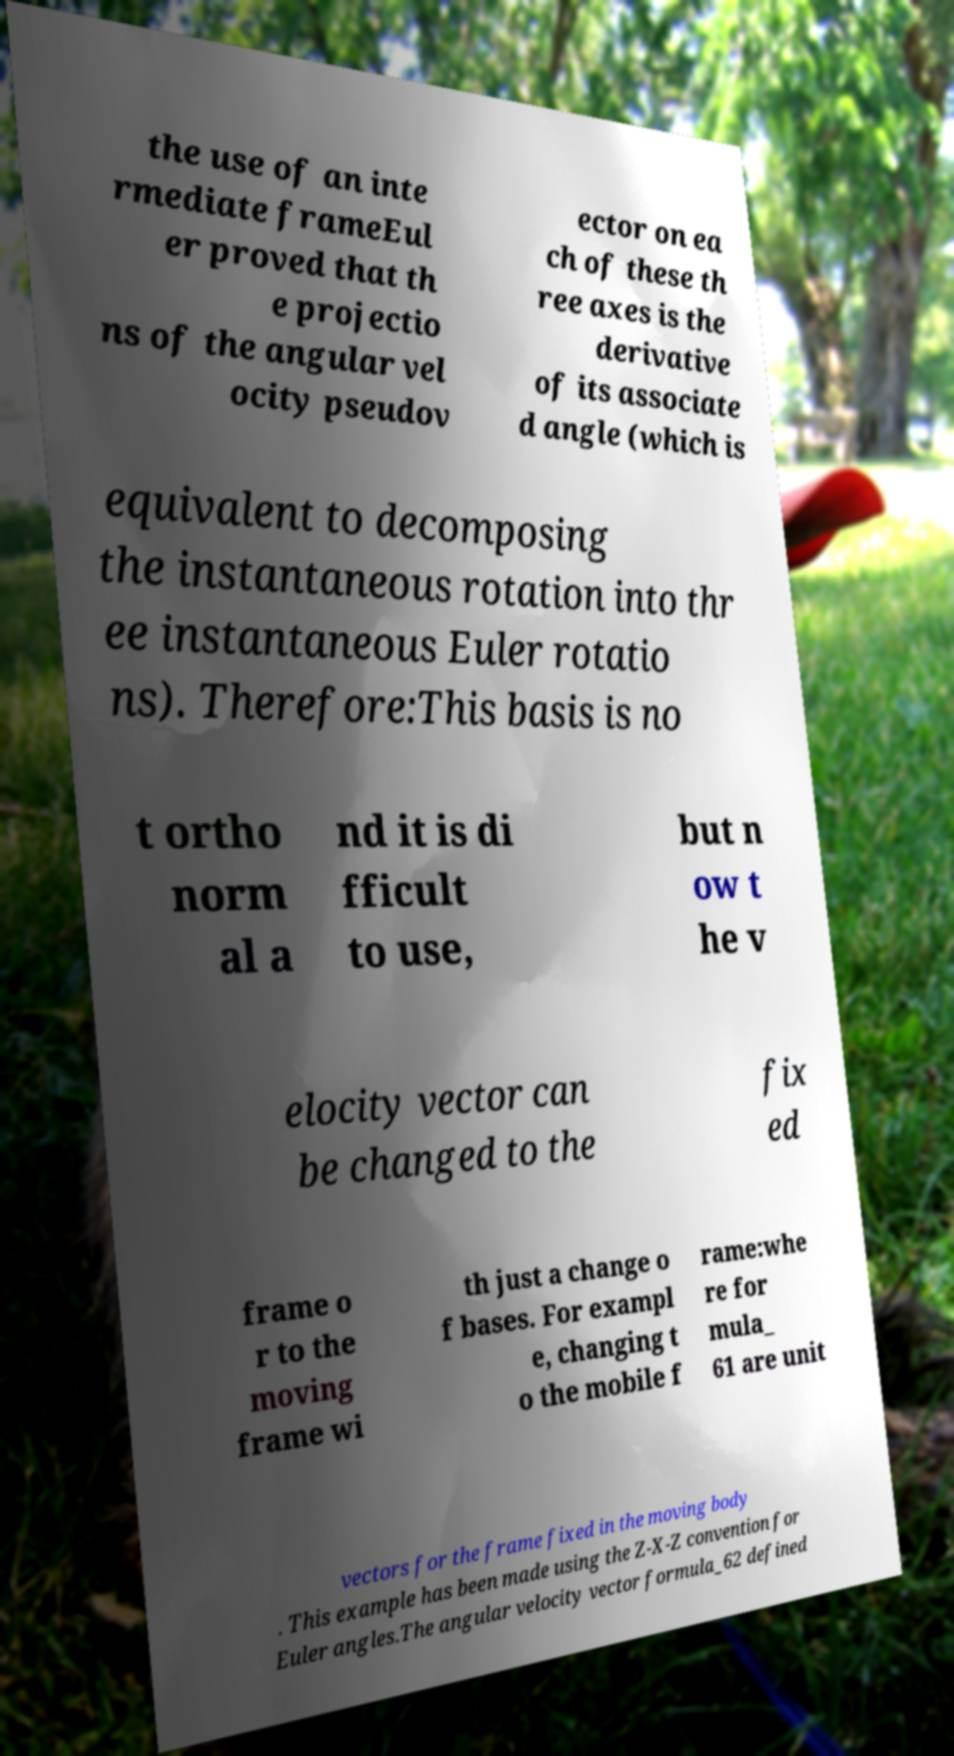Can you accurately transcribe the text from the provided image for me? the use of an inte rmediate frameEul er proved that th e projectio ns of the angular vel ocity pseudov ector on ea ch of these th ree axes is the derivative of its associate d angle (which is equivalent to decomposing the instantaneous rotation into thr ee instantaneous Euler rotatio ns). Therefore:This basis is no t ortho norm al a nd it is di fficult to use, but n ow t he v elocity vector can be changed to the fix ed frame o r to the moving frame wi th just a change o f bases. For exampl e, changing t o the mobile f rame:whe re for mula_ 61 are unit vectors for the frame fixed in the moving body . This example has been made using the Z-X-Z convention for Euler angles.The angular velocity vector formula_62 defined 